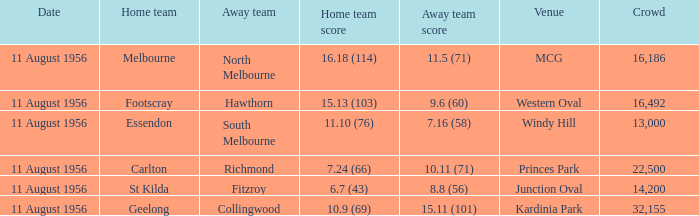What is the home team score for Footscray? 15.13 (103). 